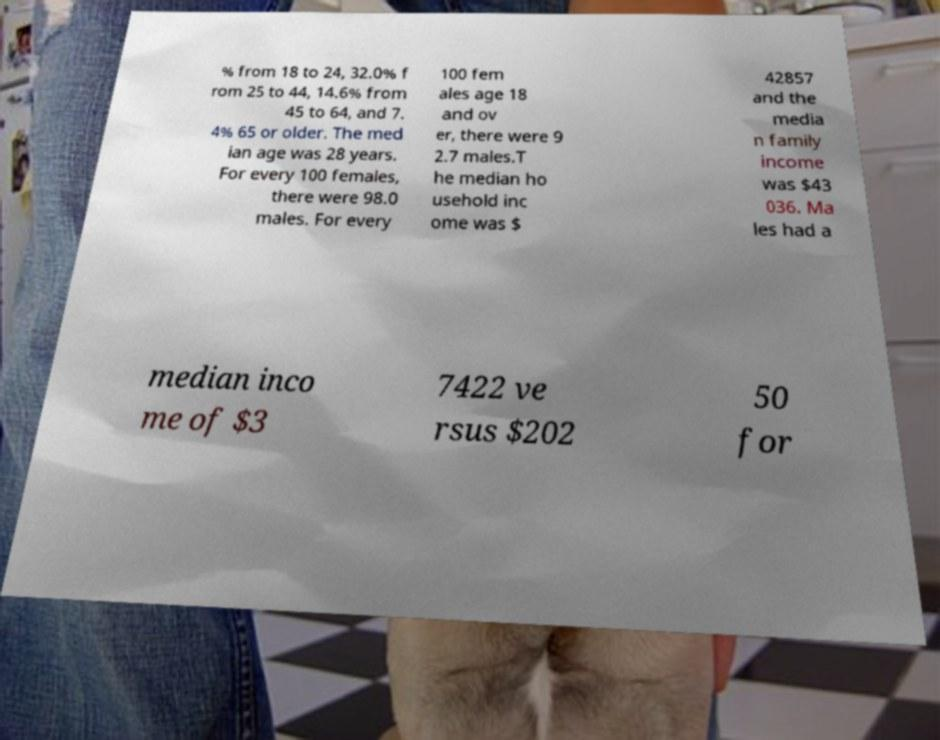Could you assist in decoding the text presented in this image and type it out clearly? % from 18 to 24, 32.0% f rom 25 to 44, 14.6% from 45 to 64, and 7. 4% 65 or older. The med ian age was 28 years. For every 100 females, there were 98.0 males. For every 100 fem ales age 18 and ov er, there were 9 2.7 males.T he median ho usehold inc ome was $ 42857 and the media n family income was $43 036. Ma les had a median inco me of $3 7422 ve rsus $202 50 for 